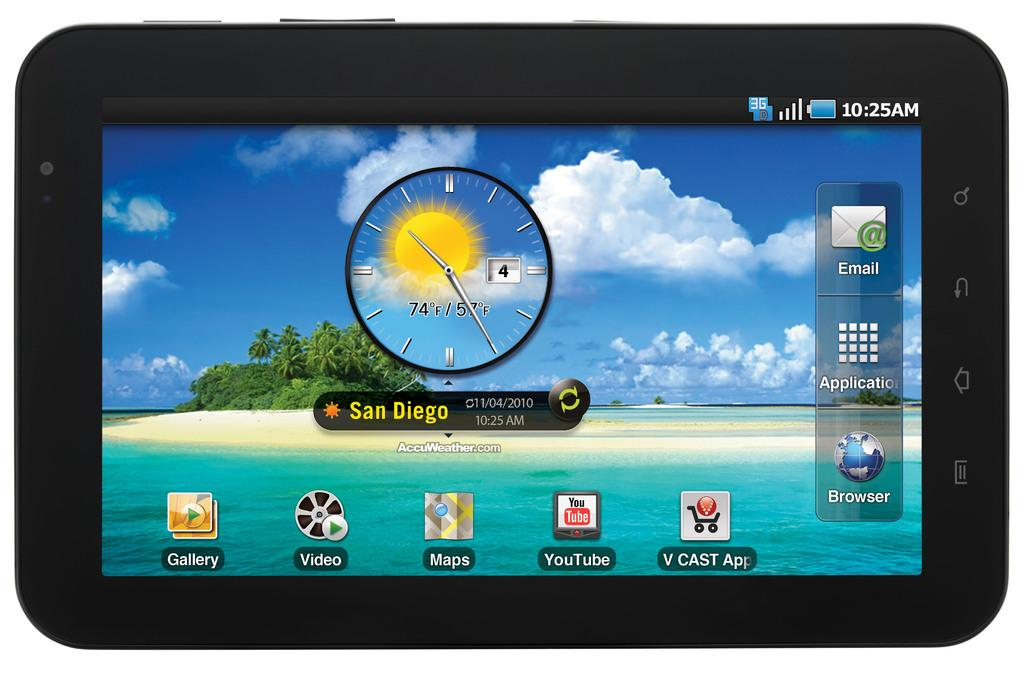<image>
Give a short and clear explanation of the subsequent image. An information screen displays the current weather in San Diego. 